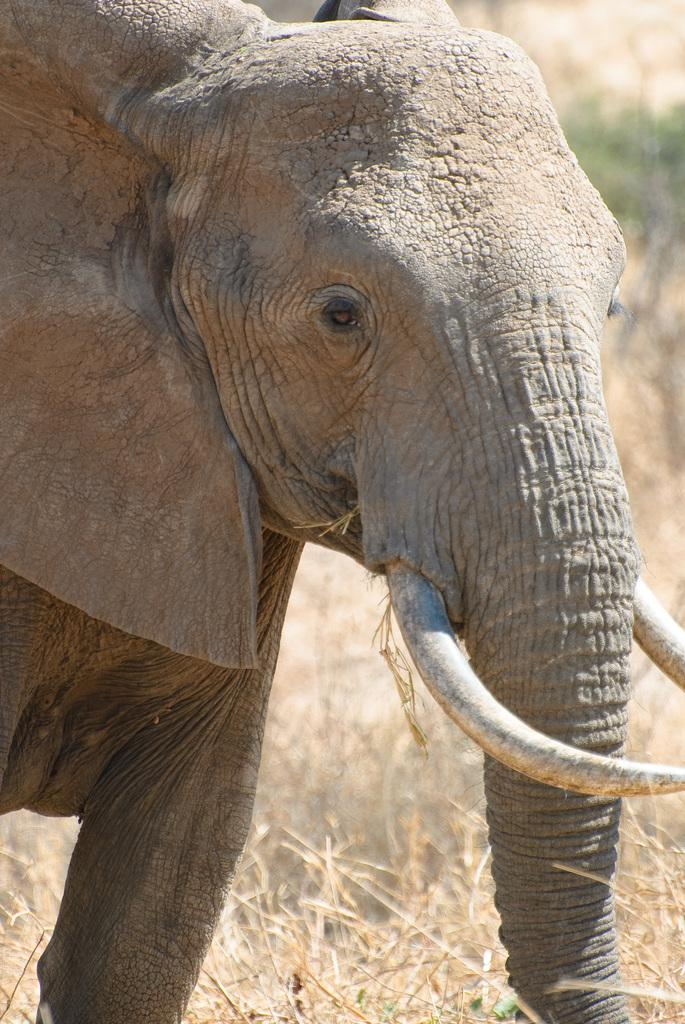What animal is present in the image? There is an elephant in the image. What type of vegetation can be seen at the bottom of the image? There is grass at the bottom of the image. What type of flower can be seen in the lunchroom in the image? There is no flower or lunchroom present in the image; it features an elephant and grass. 